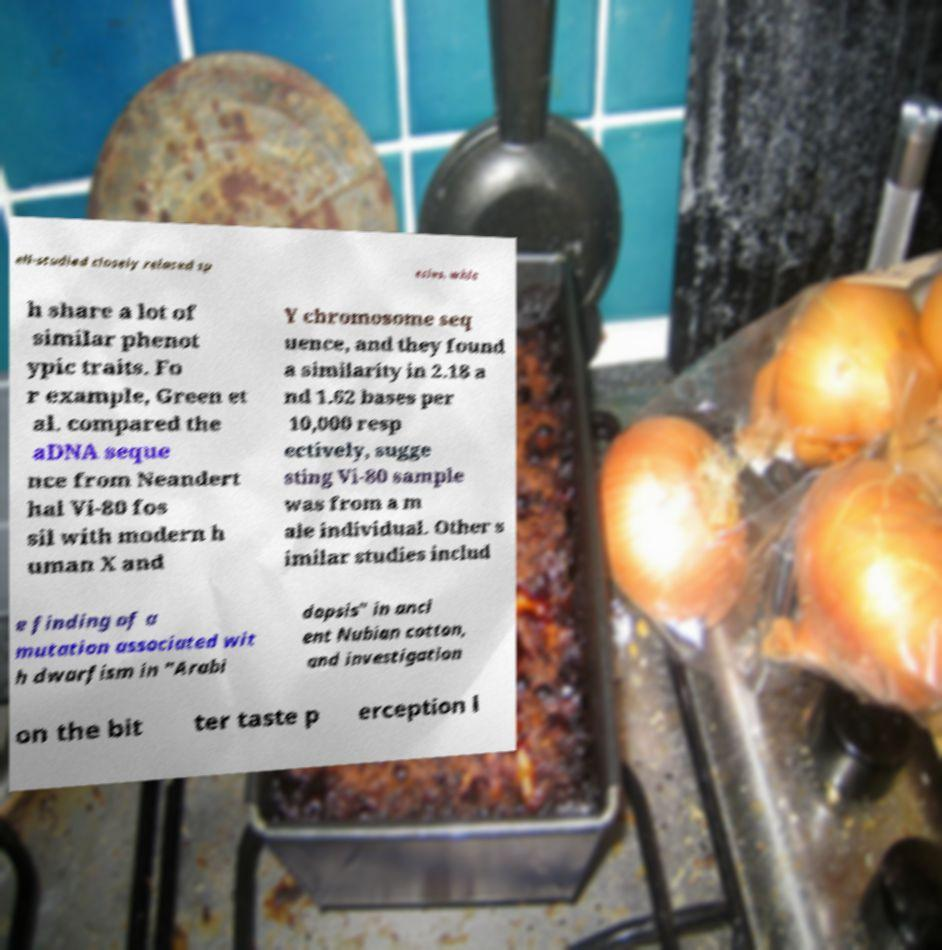Could you extract and type out the text from this image? ell-studied closely related sp ecies, whic h share a lot of similar phenot ypic traits. Fo r example, Green et al. compared the aDNA seque nce from Neandert hal Vi-80 fos sil with modern h uman X and Y chromosome seq uence, and they found a similarity in 2.18 a nd 1.62 bases per 10,000 resp ectively, sugge sting Vi-80 sample was from a m ale individual. Other s imilar studies includ e finding of a mutation associated wit h dwarfism in "Arabi dopsis" in anci ent Nubian cotton, and investigation on the bit ter taste p erception l 